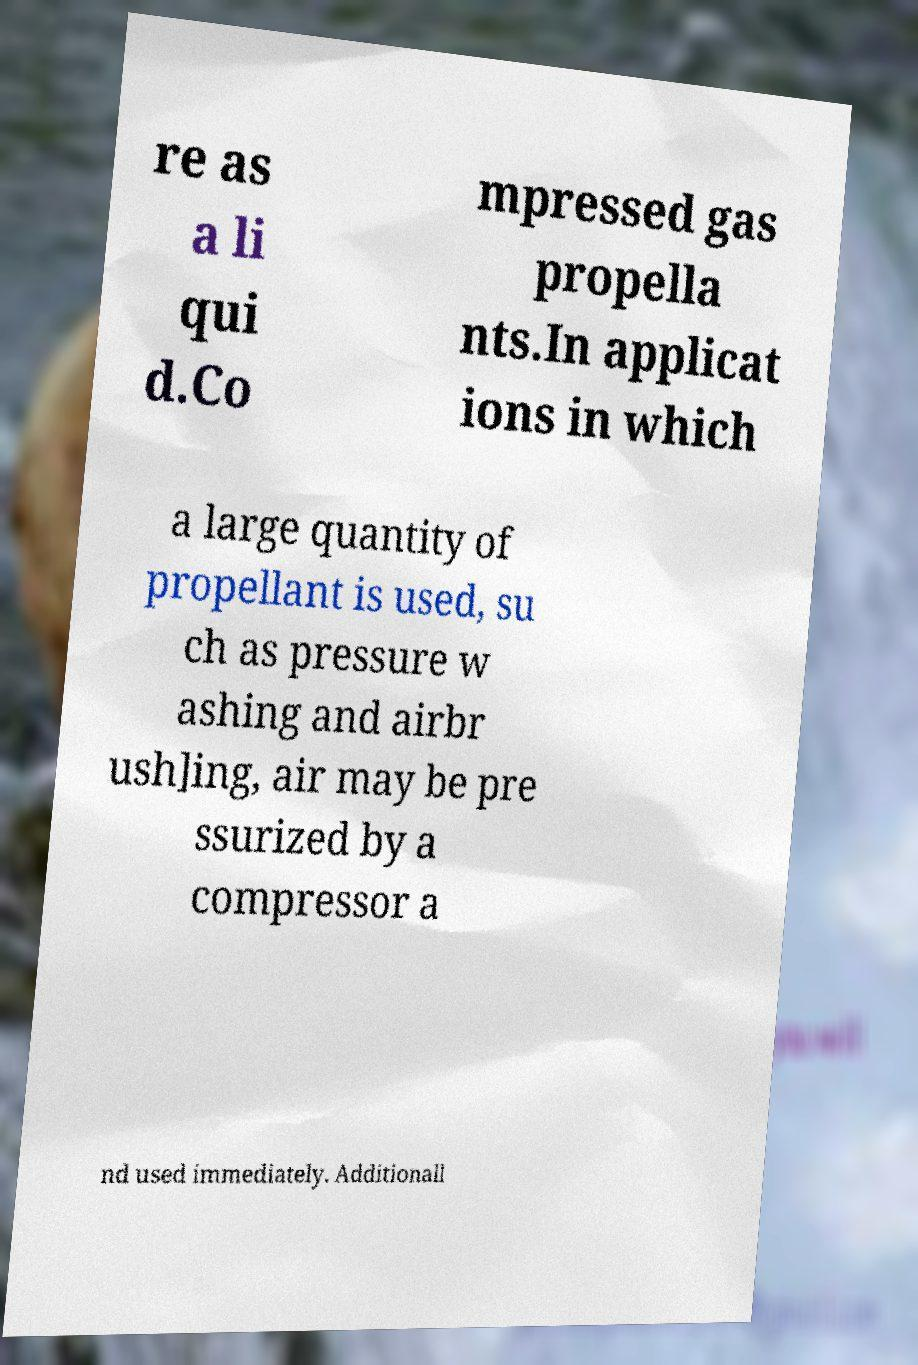Can you read and provide the text displayed in the image?This photo seems to have some interesting text. Can you extract and type it out for me? re as a li qui d.Co mpressed gas propella nts.In applicat ions in which a large quantity of propellant is used, su ch as pressure w ashing and airbr ush]ing, air may be pre ssurized by a compressor a nd used immediately. Additionall 